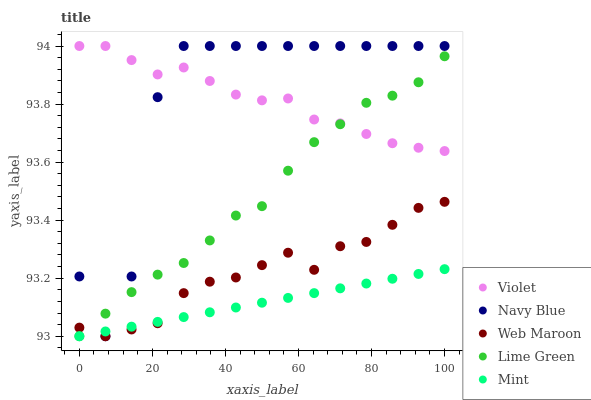Does Mint have the minimum area under the curve?
Answer yes or no. Yes. Does Navy Blue have the maximum area under the curve?
Answer yes or no. Yes. Does Web Maroon have the minimum area under the curve?
Answer yes or no. No. Does Web Maroon have the maximum area under the curve?
Answer yes or no. No. Is Mint the smoothest?
Answer yes or no. Yes. Is Navy Blue the roughest?
Answer yes or no. Yes. Is Web Maroon the smoothest?
Answer yes or no. No. Is Web Maroon the roughest?
Answer yes or no. No. Does Web Maroon have the lowest value?
Answer yes or no. Yes. Does Violet have the lowest value?
Answer yes or no. No. Does Violet have the highest value?
Answer yes or no. Yes. Does Web Maroon have the highest value?
Answer yes or no. No. Is Web Maroon less than Violet?
Answer yes or no. Yes. Is Navy Blue greater than Web Maroon?
Answer yes or no. Yes. Does Lime Green intersect Web Maroon?
Answer yes or no. Yes. Is Lime Green less than Web Maroon?
Answer yes or no. No. Is Lime Green greater than Web Maroon?
Answer yes or no. No. Does Web Maroon intersect Violet?
Answer yes or no. No. 